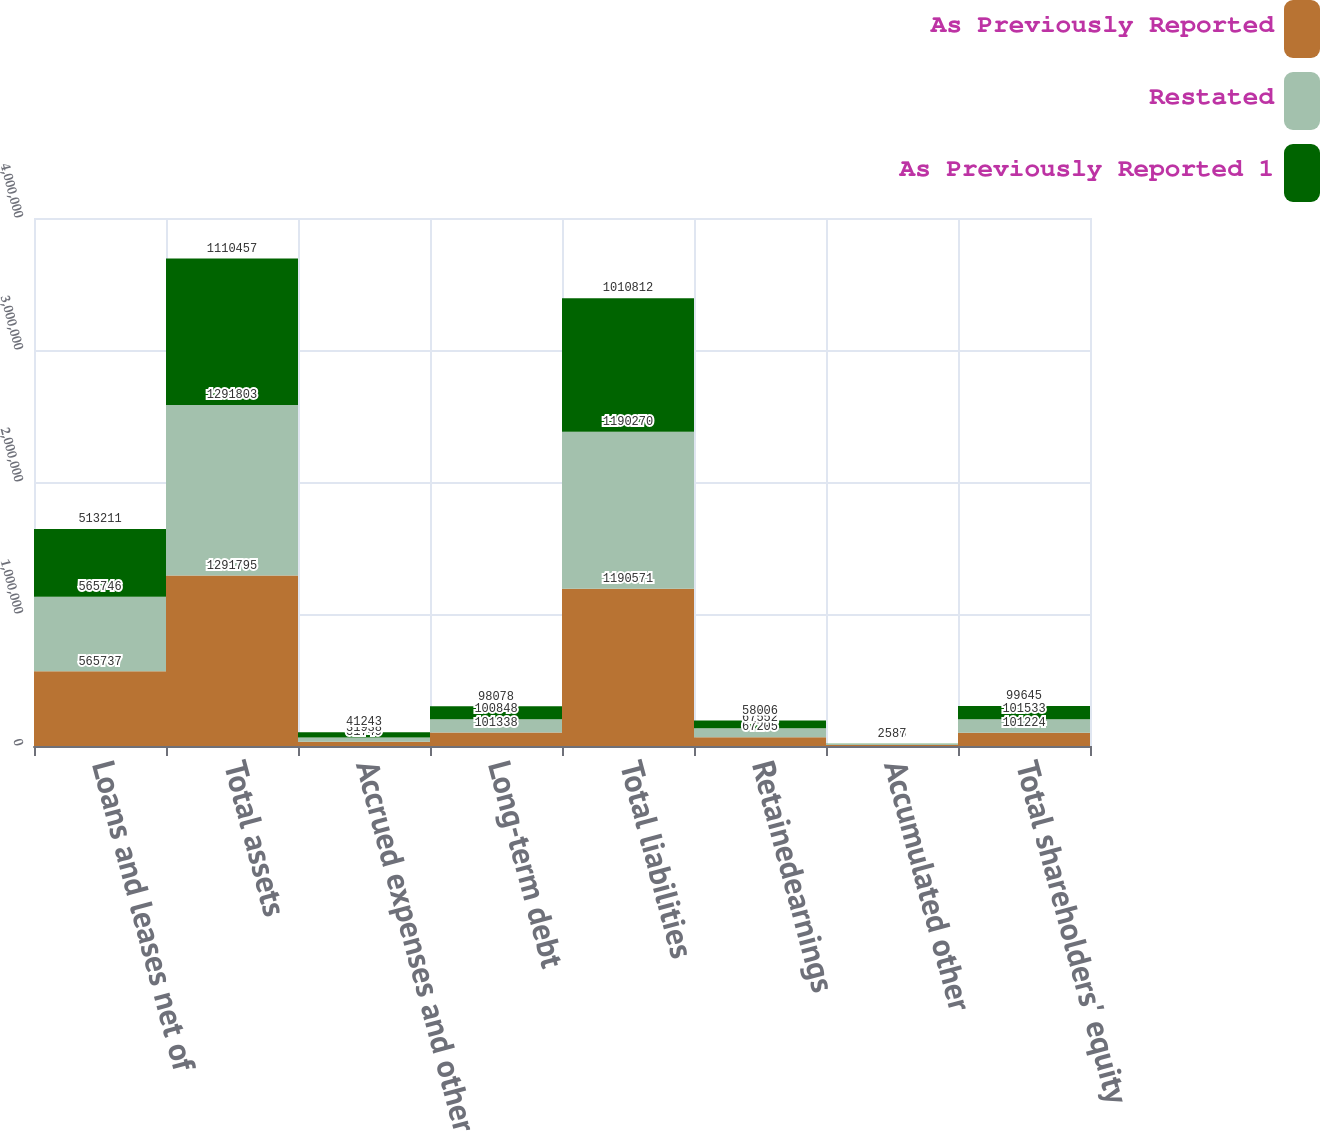Convert chart. <chart><loc_0><loc_0><loc_500><loc_500><stacked_bar_chart><ecel><fcel>Loans and leases net of<fcel>Total assets<fcel>Accrued expenses and other<fcel>Long-term debt<fcel>Total liabilities<fcel>Retainedearnings<fcel>Accumulated other<fcel>Total shareholders' equity<nl><fcel>As Previously Reported<fcel>565737<fcel>1.2918e+06<fcel>31749<fcel>101338<fcel>1.19057e+06<fcel>67205<fcel>7518<fcel>101224<nl><fcel>Restated<fcel>565746<fcel>1.2918e+06<fcel>31938<fcel>100848<fcel>1.19027e+06<fcel>67552<fcel>7556<fcel>101533<nl><fcel>As Previously Reported 1<fcel>513211<fcel>1.11046e+06<fcel>41243<fcel>98078<fcel>1.01081e+06<fcel>58006<fcel>2587<fcel>99645<nl></chart> 